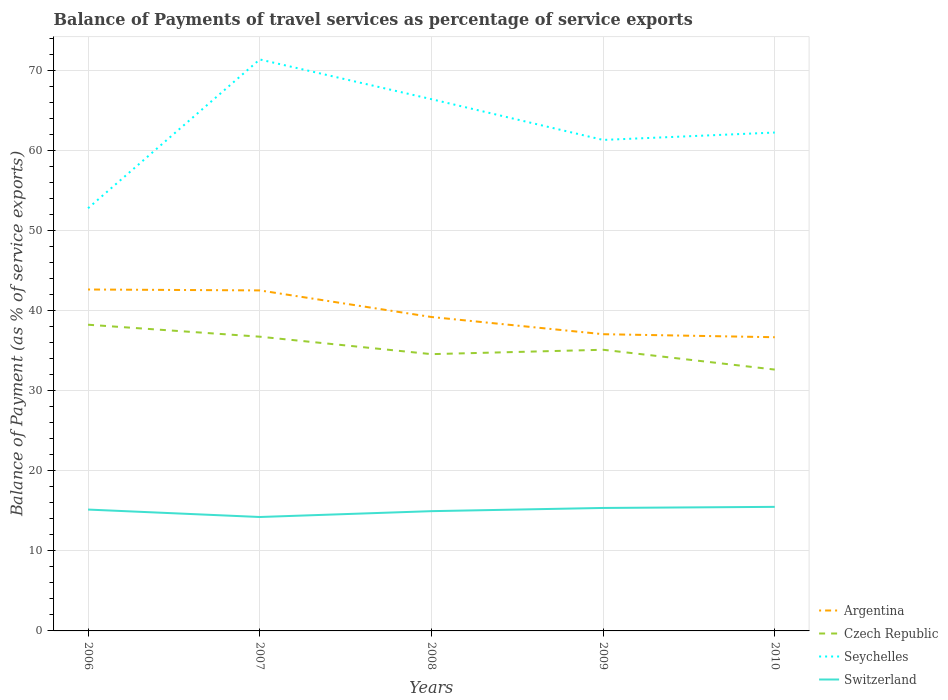Across all years, what is the maximum balance of payments of travel services in Czech Republic?
Offer a very short reply. 32.66. In which year was the balance of payments of travel services in Argentina maximum?
Provide a short and direct response. 2010. What is the total balance of payments of travel services in Czech Republic in the graph?
Your answer should be compact. 2.48. What is the difference between the highest and the second highest balance of payments of travel services in Czech Republic?
Offer a very short reply. 5.61. Is the balance of payments of travel services in Czech Republic strictly greater than the balance of payments of travel services in Seychelles over the years?
Offer a very short reply. Yes. Does the graph contain grids?
Provide a short and direct response. Yes. How many legend labels are there?
Offer a terse response. 4. How are the legend labels stacked?
Make the answer very short. Vertical. What is the title of the graph?
Your answer should be compact. Balance of Payments of travel services as percentage of service exports. Does "Arab World" appear as one of the legend labels in the graph?
Offer a terse response. No. What is the label or title of the X-axis?
Make the answer very short. Years. What is the label or title of the Y-axis?
Provide a succinct answer. Balance of Payment (as % of service exports). What is the Balance of Payment (as % of service exports) of Argentina in 2006?
Your response must be concise. 42.67. What is the Balance of Payment (as % of service exports) in Czech Republic in 2006?
Provide a short and direct response. 38.27. What is the Balance of Payment (as % of service exports) of Seychelles in 2006?
Your response must be concise. 52.83. What is the Balance of Payment (as % of service exports) of Switzerland in 2006?
Make the answer very short. 15.17. What is the Balance of Payment (as % of service exports) in Argentina in 2007?
Give a very brief answer. 42.56. What is the Balance of Payment (as % of service exports) in Czech Republic in 2007?
Your response must be concise. 36.77. What is the Balance of Payment (as % of service exports) in Seychelles in 2007?
Ensure brevity in your answer.  71.42. What is the Balance of Payment (as % of service exports) in Switzerland in 2007?
Offer a very short reply. 14.24. What is the Balance of Payment (as % of service exports) in Argentina in 2008?
Give a very brief answer. 39.23. What is the Balance of Payment (as % of service exports) of Czech Republic in 2008?
Offer a very short reply. 34.59. What is the Balance of Payment (as % of service exports) in Seychelles in 2008?
Your answer should be very brief. 66.46. What is the Balance of Payment (as % of service exports) in Switzerland in 2008?
Your answer should be compact. 14.97. What is the Balance of Payment (as % of service exports) in Argentina in 2009?
Keep it short and to the point. 37.08. What is the Balance of Payment (as % of service exports) in Czech Republic in 2009?
Your answer should be compact. 35.14. What is the Balance of Payment (as % of service exports) in Seychelles in 2009?
Offer a terse response. 61.36. What is the Balance of Payment (as % of service exports) in Switzerland in 2009?
Keep it short and to the point. 15.37. What is the Balance of Payment (as % of service exports) in Argentina in 2010?
Ensure brevity in your answer.  36.71. What is the Balance of Payment (as % of service exports) of Czech Republic in 2010?
Provide a short and direct response. 32.66. What is the Balance of Payment (as % of service exports) of Seychelles in 2010?
Your response must be concise. 62.29. What is the Balance of Payment (as % of service exports) in Switzerland in 2010?
Provide a short and direct response. 15.51. Across all years, what is the maximum Balance of Payment (as % of service exports) of Argentina?
Your response must be concise. 42.67. Across all years, what is the maximum Balance of Payment (as % of service exports) in Czech Republic?
Ensure brevity in your answer.  38.27. Across all years, what is the maximum Balance of Payment (as % of service exports) in Seychelles?
Give a very brief answer. 71.42. Across all years, what is the maximum Balance of Payment (as % of service exports) in Switzerland?
Make the answer very short. 15.51. Across all years, what is the minimum Balance of Payment (as % of service exports) of Argentina?
Provide a short and direct response. 36.71. Across all years, what is the minimum Balance of Payment (as % of service exports) of Czech Republic?
Your answer should be very brief. 32.66. Across all years, what is the minimum Balance of Payment (as % of service exports) in Seychelles?
Your answer should be compact. 52.83. Across all years, what is the minimum Balance of Payment (as % of service exports) in Switzerland?
Provide a short and direct response. 14.24. What is the total Balance of Payment (as % of service exports) in Argentina in the graph?
Provide a short and direct response. 198.25. What is the total Balance of Payment (as % of service exports) of Czech Republic in the graph?
Keep it short and to the point. 177.44. What is the total Balance of Payment (as % of service exports) in Seychelles in the graph?
Offer a very short reply. 314.36. What is the total Balance of Payment (as % of service exports) of Switzerland in the graph?
Offer a terse response. 75.25. What is the difference between the Balance of Payment (as % of service exports) in Argentina in 2006 and that in 2007?
Make the answer very short. 0.11. What is the difference between the Balance of Payment (as % of service exports) of Czech Republic in 2006 and that in 2007?
Provide a succinct answer. 1.5. What is the difference between the Balance of Payment (as % of service exports) of Seychelles in 2006 and that in 2007?
Your answer should be compact. -18.6. What is the difference between the Balance of Payment (as % of service exports) in Switzerland in 2006 and that in 2007?
Your answer should be compact. 0.93. What is the difference between the Balance of Payment (as % of service exports) in Argentina in 2006 and that in 2008?
Ensure brevity in your answer.  3.44. What is the difference between the Balance of Payment (as % of service exports) of Czech Republic in 2006 and that in 2008?
Offer a terse response. 3.68. What is the difference between the Balance of Payment (as % of service exports) of Seychelles in 2006 and that in 2008?
Offer a terse response. -13.63. What is the difference between the Balance of Payment (as % of service exports) in Switzerland in 2006 and that in 2008?
Offer a very short reply. 0.2. What is the difference between the Balance of Payment (as % of service exports) in Argentina in 2006 and that in 2009?
Ensure brevity in your answer.  5.59. What is the difference between the Balance of Payment (as % of service exports) in Czech Republic in 2006 and that in 2009?
Your answer should be compact. 3.13. What is the difference between the Balance of Payment (as % of service exports) in Seychelles in 2006 and that in 2009?
Make the answer very short. -8.54. What is the difference between the Balance of Payment (as % of service exports) of Switzerland in 2006 and that in 2009?
Offer a terse response. -0.2. What is the difference between the Balance of Payment (as % of service exports) of Argentina in 2006 and that in 2010?
Provide a short and direct response. 5.97. What is the difference between the Balance of Payment (as % of service exports) in Czech Republic in 2006 and that in 2010?
Keep it short and to the point. 5.61. What is the difference between the Balance of Payment (as % of service exports) in Seychelles in 2006 and that in 2010?
Provide a short and direct response. -9.46. What is the difference between the Balance of Payment (as % of service exports) of Switzerland in 2006 and that in 2010?
Offer a terse response. -0.34. What is the difference between the Balance of Payment (as % of service exports) of Argentina in 2007 and that in 2008?
Offer a very short reply. 3.32. What is the difference between the Balance of Payment (as % of service exports) in Czech Republic in 2007 and that in 2008?
Provide a short and direct response. 2.18. What is the difference between the Balance of Payment (as % of service exports) in Seychelles in 2007 and that in 2008?
Your response must be concise. 4.96. What is the difference between the Balance of Payment (as % of service exports) of Switzerland in 2007 and that in 2008?
Keep it short and to the point. -0.73. What is the difference between the Balance of Payment (as % of service exports) in Argentina in 2007 and that in 2009?
Offer a very short reply. 5.47. What is the difference between the Balance of Payment (as % of service exports) in Czech Republic in 2007 and that in 2009?
Your answer should be compact. 1.63. What is the difference between the Balance of Payment (as % of service exports) in Seychelles in 2007 and that in 2009?
Make the answer very short. 10.06. What is the difference between the Balance of Payment (as % of service exports) of Switzerland in 2007 and that in 2009?
Your response must be concise. -1.13. What is the difference between the Balance of Payment (as % of service exports) of Argentina in 2007 and that in 2010?
Provide a succinct answer. 5.85. What is the difference between the Balance of Payment (as % of service exports) of Czech Republic in 2007 and that in 2010?
Make the answer very short. 4.11. What is the difference between the Balance of Payment (as % of service exports) of Seychelles in 2007 and that in 2010?
Keep it short and to the point. 9.13. What is the difference between the Balance of Payment (as % of service exports) in Switzerland in 2007 and that in 2010?
Provide a succinct answer. -1.27. What is the difference between the Balance of Payment (as % of service exports) in Argentina in 2008 and that in 2009?
Make the answer very short. 2.15. What is the difference between the Balance of Payment (as % of service exports) in Czech Republic in 2008 and that in 2009?
Provide a succinct answer. -0.55. What is the difference between the Balance of Payment (as % of service exports) of Seychelles in 2008 and that in 2009?
Your answer should be very brief. 5.1. What is the difference between the Balance of Payment (as % of service exports) of Switzerland in 2008 and that in 2009?
Make the answer very short. -0.4. What is the difference between the Balance of Payment (as % of service exports) of Argentina in 2008 and that in 2010?
Keep it short and to the point. 2.53. What is the difference between the Balance of Payment (as % of service exports) in Czech Republic in 2008 and that in 2010?
Give a very brief answer. 1.93. What is the difference between the Balance of Payment (as % of service exports) in Seychelles in 2008 and that in 2010?
Provide a succinct answer. 4.17. What is the difference between the Balance of Payment (as % of service exports) of Switzerland in 2008 and that in 2010?
Your response must be concise. -0.54. What is the difference between the Balance of Payment (as % of service exports) of Argentina in 2009 and that in 2010?
Give a very brief answer. 0.38. What is the difference between the Balance of Payment (as % of service exports) in Czech Republic in 2009 and that in 2010?
Ensure brevity in your answer.  2.48. What is the difference between the Balance of Payment (as % of service exports) of Seychelles in 2009 and that in 2010?
Keep it short and to the point. -0.92. What is the difference between the Balance of Payment (as % of service exports) in Switzerland in 2009 and that in 2010?
Offer a terse response. -0.14. What is the difference between the Balance of Payment (as % of service exports) of Argentina in 2006 and the Balance of Payment (as % of service exports) of Czech Republic in 2007?
Make the answer very short. 5.9. What is the difference between the Balance of Payment (as % of service exports) in Argentina in 2006 and the Balance of Payment (as % of service exports) in Seychelles in 2007?
Ensure brevity in your answer.  -28.75. What is the difference between the Balance of Payment (as % of service exports) in Argentina in 2006 and the Balance of Payment (as % of service exports) in Switzerland in 2007?
Provide a succinct answer. 28.43. What is the difference between the Balance of Payment (as % of service exports) of Czech Republic in 2006 and the Balance of Payment (as % of service exports) of Seychelles in 2007?
Provide a short and direct response. -33.15. What is the difference between the Balance of Payment (as % of service exports) in Czech Republic in 2006 and the Balance of Payment (as % of service exports) in Switzerland in 2007?
Provide a short and direct response. 24.03. What is the difference between the Balance of Payment (as % of service exports) of Seychelles in 2006 and the Balance of Payment (as % of service exports) of Switzerland in 2007?
Ensure brevity in your answer.  38.59. What is the difference between the Balance of Payment (as % of service exports) in Argentina in 2006 and the Balance of Payment (as % of service exports) in Czech Republic in 2008?
Keep it short and to the point. 8.08. What is the difference between the Balance of Payment (as % of service exports) in Argentina in 2006 and the Balance of Payment (as % of service exports) in Seychelles in 2008?
Provide a succinct answer. -23.79. What is the difference between the Balance of Payment (as % of service exports) of Argentina in 2006 and the Balance of Payment (as % of service exports) of Switzerland in 2008?
Give a very brief answer. 27.7. What is the difference between the Balance of Payment (as % of service exports) of Czech Republic in 2006 and the Balance of Payment (as % of service exports) of Seychelles in 2008?
Make the answer very short. -28.19. What is the difference between the Balance of Payment (as % of service exports) of Czech Republic in 2006 and the Balance of Payment (as % of service exports) of Switzerland in 2008?
Provide a succinct answer. 23.3. What is the difference between the Balance of Payment (as % of service exports) in Seychelles in 2006 and the Balance of Payment (as % of service exports) in Switzerland in 2008?
Your answer should be compact. 37.86. What is the difference between the Balance of Payment (as % of service exports) of Argentina in 2006 and the Balance of Payment (as % of service exports) of Czech Republic in 2009?
Make the answer very short. 7.53. What is the difference between the Balance of Payment (as % of service exports) of Argentina in 2006 and the Balance of Payment (as % of service exports) of Seychelles in 2009?
Make the answer very short. -18.69. What is the difference between the Balance of Payment (as % of service exports) in Argentina in 2006 and the Balance of Payment (as % of service exports) in Switzerland in 2009?
Offer a very short reply. 27.3. What is the difference between the Balance of Payment (as % of service exports) in Czech Republic in 2006 and the Balance of Payment (as % of service exports) in Seychelles in 2009?
Offer a terse response. -23.09. What is the difference between the Balance of Payment (as % of service exports) in Czech Republic in 2006 and the Balance of Payment (as % of service exports) in Switzerland in 2009?
Ensure brevity in your answer.  22.9. What is the difference between the Balance of Payment (as % of service exports) in Seychelles in 2006 and the Balance of Payment (as % of service exports) in Switzerland in 2009?
Ensure brevity in your answer.  37.46. What is the difference between the Balance of Payment (as % of service exports) in Argentina in 2006 and the Balance of Payment (as % of service exports) in Czech Republic in 2010?
Provide a short and direct response. 10.01. What is the difference between the Balance of Payment (as % of service exports) in Argentina in 2006 and the Balance of Payment (as % of service exports) in Seychelles in 2010?
Your answer should be compact. -19.62. What is the difference between the Balance of Payment (as % of service exports) in Argentina in 2006 and the Balance of Payment (as % of service exports) in Switzerland in 2010?
Make the answer very short. 27.17. What is the difference between the Balance of Payment (as % of service exports) in Czech Republic in 2006 and the Balance of Payment (as % of service exports) in Seychelles in 2010?
Your answer should be very brief. -24.02. What is the difference between the Balance of Payment (as % of service exports) in Czech Republic in 2006 and the Balance of Payment (as % of service exports) in Switzerland in 2010?
Keep it short and to the point. 22.76. What is the difference between the Balance of Payment (as % of service exports) of Seychelles in 2006 and the Balance of Payment (as % of service exports) of Switzerland in 2010?
Offer a very short reply. 37.32. What is the difference between the Balance of Payment (as % of service exports) of Argentina in 2007 and the Balance of Payment (as % of service exports) of Czech Republic in 2008?
Provide a short and direct response. 7.97. What is the difference between the Balance of Payment (as % of service exports) of Argentina in 2007 and the Balance of Payment (as % of service exports) of Seychelles in 2008?
Keep it short and to the point. -23.9. What is the difference between the Balance of Payment (as % of service exports) in Argentina in 2007 and the Balance of Payment (as % of service exports) in Switzerland in 2008?
Provide a succinct answer. 27.59. What is the difference between the Balance of Payment (as % of service exports) of Czech Republic in 2007 and the Balance of Payment (as % of service exports) of Seychelles in 2008?
Provide a short and direct response. -29.69. What is the difference between the Balance of Payment (as % of service exports) in Czech Republic in 2007 and the Balance of Payment (as % of service exports) in Switzerland in 2008?
Provide a short and direct response. 21.81. What is the difference between the Balance of Payment (as % of service exports) in Seychelles in 2007 and the Balance of Payment (as % of service exports) in Switzerland in 2008?
Make the answer very short. 56.46. What is the difference between the Balance of Payment (as % of service exports) in Argentina in 2007 and the Balance of Payment (as % of service exports) in Czech Republic in 2009?
Provide a succinct answer. 7.42. What is the difference between the Balance of Payment (as % of service exports) in Argentina in 2007 and the Balance of Payment (as % of service exports) in Seychelles in 2009?
Your answer should be compact. -18.81. What is the difference between the Balance of Payment (as % of service exports) in Argentina in 2007 and the Balance of Payment (as % of service exports) in Switzerland in 2009?
Keep it short and to the point. 27.19. What is the difference between the Balance of Payment (as % of service exports) of Czech Republic in 2007 and the Balance of Payment (as % of service exports) of Seychelles in 2009?
Provide a succinct answer. -24.59. What is the difference between the Balance of Payment (as % of service exports) in Czech Republic in 2007 and the Balance of Payment (as % of service exports) in Switzerland in 2009?
Offer a very short reply. 21.41. What is the difference between the Balance of Payment (as % of service exports) in Seychelles in 2007 and the Balance of Payment (as % of service exports) in Switzerland in 2009?
Your answer should be compact. 56.05. What is the difference between the Balance of Payment (as % of service exports) of Argentina in 2007 and the Balance of Payment (as % of service exports) of Czech Republic in 2010?
Make the answer very short. 9.9. What is the difference between the Balance of Payment (as % of service exports) of Argentina in 2007 and the Balance of Payment (as % of service exports) of Seychelles in 2010?
Your answer should be compact. -19.73. What is the difference between the Balance of Payment (as % of service exports) of Argentina in 2007 and the Balance of Payment (as % of service exports) of Switzerland in 2010?
Provide a short and direct response. 27.05. What is the difference between the Balance of Payment (as % of service exports) of Czech Republic in 2007 and the Balance of Payment (as % of service exports) of Seychelles in 2010?
Give a very brief answer. -25.51. What is the difference between the Balance of Payment (as % of service exports) in Czech Republic in 2007 and the Balance of Payment (as % of service exports) in Switzerland in 2010?
Your answer should be compact. 21.27. What is the difference between the Balance of Payment (as % of service exports) of Seychelles in 2007 and the Balance of Payment (as % of service exports) of Switzerland in 2010?
Your answer should be very brief. 55.92. What is the difference between the Balance of Payment (as % of service exports) of Argentina in 2008 and the Balance of Payment (as % of service exports) of Czech Republic in 2009?
Ensure brevity in your answer.  4.09. What is the difference between the Balance of Payment (as % of service exports) of Argentina in 2008 and the Balance of Payment (as % of service exports) of Seychelles in 2009?
Provide a succinct answer. -22.13. What is the difference between the Balance of Payment (as % of service exports) of Argentina in 2008 and the Balance of Payment (as % of service exports) of Switzerland in 2009?
Ensure brevity in your answer.  23.87. What is the difference between the Balance of Payment (as % of service exports) in Czech Republic in 2008 and the Balance of Payment (as % of service exports) in Seychelles in 2009?
Provide a short and direct response. -26.77. What is the difference between the Balance of Payment (as % of service exports) of Czech Republic in 2008 and the Balance of Payment (as % of service exports) of Switzerland in 2009?
Offer a very short reply. 19.22. What is the difference between the Balance of Payment (as % of service exports) in Seychelles in 2008 and the Balance of Payment (as % of service exports) in Switzerland in 2009?
Keep it short and to the point. 51.09. What is the difference between the Balance of Payment (as % of service exports) of Argentina in 2008 and the Balance of Payment (as % of service exports) of Czech Republic in 2010?
Provide a short and direct response. 6.57. What is the difference between the Balance of Payment (as % of service exports) of Argentina in 2008 and the Balance of Payment (as % of service exports) of Seychelles in 2010?
Your answer should be compact. -23.05. What is the difference between the Balance of Payment (as % of service exports) of Argentina in 2008 and the Balance of Payment (as % of service exports) of Switzerland in 2010?
Your answer should be compact. 23.73. What is the difference between the Balance of Payment (as % of service exports) of Czech Republic in 2008 and the Balance of Payment (as % of service exports) of Seychelles in 2010?
Your answer should be very brief. -27.7. What is the difference between the Balance of Payment (as % of service exports) in Czech Republic in 2008 and the Balance of Payment (as % of service exports) in Switzerland in 2010?
Give a very brief answer. 19.09. What is the difference between the Balance of Payment (as % of service exports) in Seychelles in 2008 and the Balance of Payment (as % of service exports) in Switzerland in 2010?
Provide a succinct answer. 50.95. What is the difference between the Balance of Payment (as % of service exports) in Argentina in 2009 and the Balance of Payment (as % of service exports) in Czech Republic in 2010?
Give a very brief answer. 4.42. What is the difference between the Balance of Payment (as % of service exports) of Argentina in 2009 and the Balance of Payment (as % of service exports) of Seychelles in 2010?
Offer a very short reply. -25.2. What is the difference between the Balance of Payment (as % of service exports) in Argentina in 2009 and the Balance of Payment (as % of service exports) in Switzerland in 2010?
Your answer should be compact. 21.58. What is the difference between the Balance of Payment (as % of service exports) in Czech Republic in 2009 and the Balance of Payment (as % of service exports) in Seychelles in 2010?
Provide a short and direct response. -27.15. What is the difference between the Balance of Payment (as % of service exports) of Czech Republic in 2009 and the Balance of Payment (as % of service exports) of Switzerland in 2010?
Offer a very short reply. 19.64. What is the difference between the Balance of Payment (as % of service exports) in Seychelles in 2009 and the Balance of Payment (as % of service exports) in Switzerland in 2010?
Your answer should be compact. 45.86. What is the average Balance of Payment (as % of service exports) of Argentina per year?
Give a very brief answer. 39.65. What is the average Balance of Payment (as % of service exports) in Czech Republic per year?
Your answer should be very brief. 35.49. What is the average Balance of Payment (as % of service exports) of Seychelles per year?
Ensure brevity in your answer.  62.87. What is the average Balance of Payment (as % of service exports) in Switzerland per year?
Your answer should be compact. 15.05. In the year 2006, what is the difference between the Balance of Payment (as % of service exports) of Argentina and Balance of Payment (as % of service exports) of Czech Republic?
Make the answer very short. 4.4. In the year 2006, what is the difference between the Balance of Payment (as % of service exports) in Argentina and Balance of Payment (as % of service exports) in Seychelles?
Your answer should be compact. -10.15. In the year 2006, what is the difference between the Balance of Payment (as % of service exports) in Argentina and Balance of Payment (as % of service exports) in Switzerland?
Keep it short and to the point. 27.5. In the year 2006, what is the difference between the Balance of Payment (as % of service exports) in Czech Republic and Balance of Payment (as % of service exports) in Seychelles?
Give a very brief answer. -14.56. In the year 2006, what is the difference between the Balance of Payment (as % of service exports) in Czech Republic and Balance of Payment (as % of service exports) in Switzerland?
Offer a very short reply. 23.1. In the year 2006, what is the difference between the Balance of Payment (as % of service exports) in Seychelles and Balance of Payment (as % of service exports) in Switzerland?
Offer a very short reply. 37.66. In the year 2007, what is the difference between the Balance of Payment (as % of service exports) of Argentina and Balance of Payment (as % of service exports) of Czech Republic?
Provide a succinct answer. 5.78. In the year 2007, what is the difference between the Balance of Payment (as % of service exports) in Argentina and Balance of Payment (as % of service exports) in Seychelles?
Give a very brief answer. -28.86. In the year 2007, what is the difference between the Balance of Payment (as % of service exports) of Argentina and Balance of Payment (as % of service exports) of Switzerland?
Make the answer very short. 28.32. In the year 2007, what is the difference between the Balance of Payment (as % of service exports) in Czech Republic and Balance of Payment (as % of service exports) in Seychelles?
Your response must be concise. -34.65. In the year 2007, what is the difference between the Balance of Payment (as % of service exports) in Czech Republic and Balance of Payment (as % of service exports) in Switzerland?
Offer a terse response. 22.54. In the year 2007, what is the difference between the Balance of Payment (as % of service exports) of Seychelles and Balance of Payment (as % of service exports) of Switzerland?
Your answer should be compact. 57.19. In the year 2008, what is the difference between the Balance of Payment (as % of service exports) of Argentina and Balance of Payment (as % of service exports) of Czech Republic?
Make the answer very short. 4.64. In the year 2008, what is the difference between the Balance of Payment (as % of service exports) of Argentina and Balance of Payment (as % of service exports) of Seychelles?
Your answer should be very brief. -27.23. In the year 2008, what is the difference between the Balance of Payment (as % of service exports) in Argentina and Balance of Payment (as % of service exports) in Switzerland?
Provide a succinct answer. 24.27. In the year 2008, what is the difference between the Balance of Payment (as % of service exports) of Czech Republic and Balance of Payment (as % of service exports) of Seychelles?
Your answer should be very brief. -31.87. In the year 2008, what is the difference between the Balance of Payment (as % of service exports) of Czech Republic and Balance of Payment (as % of service exports) of Switzerland?
Offer a terse response. 19.62. In the year 2008, what is the difference between the Balance of Payment (as % of service exports) of Seychelles and Balance of Payment (as % of service exports) of Switzerland?
Your response must be concise. 51.49. In the year 2009, what is the difference between the Balance of Payment (as % of service exports) in Argentina and Balance of Payment (as % of service exports) in Czech Republic?
Your answer should be very brief. 1.94. In the year 2009, what is the difference between the Balance of Payment (as % of service exports) of Argentina and Balance of Payment (as % of service exports) of Seychelles?
Offer a very short reply. -24.28. In the year 2009, what is the difference between the Balance of Payment (as % of service exports) in Argentina and Balance of Payment (as % of service exports) in Switzerland?
Give a very brief answer. 21.72. In the year 2009, what is the difference between the Balance of Payment (as % of service exports) in Czech Republic and Balance of Payment (as % of service exports) in Seychelles?
Your answer should be compact. -26.22. In the year 2009, what is the difference between the Balance of Payment (as % of service exports) in Czech Republic and Balance of Payment (as % of service exports) in Switzerland?
Provide a short and direct response. 19.77. In the year 2009, what is the difference between the Balance of Payment (as % of service exports) of Seychelles and Balance of Payment (as % of service exports) of Switzerland?
Provide a short and direct response. 46. In the year 2010, what is the difference between the Balance of Payment (as % of service exports) in Argentina and Balance of Payment (as % of service exports) in Czech Republic?
Provide a succinct answer. 4.04. In the year 2010, what is the difference between the Balance of Payment (as % of service exports) of Argentina and Balance of Payment (as % of service exports) of Seychelles?
Provide a succinct answer. -25.58. In the year 2010, what is the difference between the Balance of Payment (as % of service exports) in Argentina and Balance of Payment (as % of service exports) in Switzerland?
Your answer should be compact. 21.2. In the year 2010, what is the difference between the Balance of Payment (as % of service exports) in Czech Republic and Balance of Payment (as % of service exports) in Seychelles?
Your answer should be very brief. -29.63. In the year 2010, what is the difference between the Balance of Payment (as % of service exports) in Czech Republic and Balance of Payment (as % of service exports) in Switzerland?
Make the answer very short. 17.16. In the year 2010, what is the difference between the Balance of Payment (as % of service exports) of Seychelles and Balance of Payment (as % of service exports) of Switzerland?
Give a very brief answer. 46.78. What is the ratio of the Balance of Payment (as % of service exports) of Argentina in 2006 to that in 2007?
Offer a very short reply. 1. What is the ratio of the Balance of Payment (as % of service exports) in Czech Republic in 2006 to that in 2007?
Offer a very short reply. 1.04. What is the ratio of the Balance of Payment (as % of service exports) in Seychelles in 2006 to that in 2007?
Offer a very short reply. 0.74. What is the ratio of the Balance of Payment (as % of service exports) of Switzerland in 2006 to that in 2007?
Give a very brief answer. 1.07. What is the ratio of the Balance of Payment (as % of service exports) in Argentina in 2006 to that in 2008?
Give a very brief answer. 1.09. What is the ratio of the Balance of Payment (as % of service exports) in Czech Republic in 2006 to that in 2008?
Offer a very short reply. 1.11. What is the ratio of the Balance of Payment (as % of service exports) in Seychelles in 2006 to that in 2008?
Ensure brevity in your answer.  0.79. What is the ratio of the Balance of Payment (as % of service exports) in Switzerland in 2006 to that in 2008?
Your response must be concise. 1.01. What is the ratio of the Balance of Payment (as % of service exports) in Argentina in 2006 to that in 2009?
Provide a succinct answer. 1.15. What is the ratio of the Balance of Payment (as % of service exports) of Czech Republic in 2006 to that in 2009?
Provide a succinct answer. 1.09. What is the ratio of the Balance of Payment (as % of service exports) of Seychelles in 2006 to that in 2009?
Provide a short and direct response. 0.86. What is the ratio of the Balance of Payment (as % of service exports) of Switzerland in 2006 to that in 2009?
Make the answer very short. 0.99. What is the ratio of the Balance of Payment (as % of service exports) of Argentina in 2006 to that in 2010?
Offer a very short reply. 1.16. What is the ratio of the Balance of Payment (as % of service exports) of Czech Republic in 2006 to that in 2010?
Your answer should be compact. 1.17. What is the ratio of the Balance of Payment (as % of service exports) in Seychelles in 2006 to that in 2010?
Your answer should be compact. 0.85. What is the ratio of the Balance of Payment (as % of service exports) in Switzerland in 2006 to that in 2010?
Keep it short and to the point. 0.98. What is the ratio of the Balance of Payment (as % of service exports) in Argentina in 2007 to that in 2008?
Provide a short and direct response. 1.08. What is the ratio of the Balance of Payment (as % of service exports) in Czech Republic in 2007 to that in 2008?
Your answer should be very brief. 1.06. What is the ratio of the Balance of Payment (as % of service exports) in Seychelles in 2007 to that in 2008?
Offer a terse response. 1.07. What is the ratio of the Balance of Payment (as % of service exports) of Switzerland in 2007 to that in 2008?
Provide a short and direct response. 0.95. What is the ratio of the Balance of Payment (as % of service exports) of Argentina in 2007 to that in 2009?
Provide a succinct answer. 1.15. What is the ratio of the Balance of Payment (as % of service exports) in Czech Republic in 2007 to that in 2009?
Ensure brevity in your answer.  1.05. What is the ratio of the Balance of Payment (as % of service exports) in Seychelles in 2007 to that in 2009?
Offer a very short reply. 1.16. What is the ratio of the Balance of Payment (as % of service exports) in Switzerland in 2007 to that in 2009?
Make the answer very short. 0.93. What is the ratio of the Balance of Payment (as % of service exports) of Argentina in 2007 to that in 2010?
Your response must be concise. 1.16. What is the ratio of the Balance of Payment (as % of service exports) of Czech Republic in 2007 to that in 2010?
Keep it short and to the point. 1.13. What is the ratio of the Balance of Payment (as % of service exports) of Seychelles in 2007 to that in 2010?
Your response must be concise. 1.15. What is the ratio of the Balance of Payment (as % of service exports) of Switzerland in 2007 to that in 2010?
Provide a short and direct response. 0.92. What is the ratio of the Balance of Payment (as % of service exports) in Argentina in 2008 to that in 2009?
Provide a succinct answer. 1.06. What is the ratio of the Balance of Payment (as % of service exports) of Czech Republic in 2008 to that in 2009?
Give a very brief answer. 0.98. What is the ratio of the Balance of Payment (as % of service exports) in Seychelles in 2008 to that in 2009?
Your answer should be compact. 1.08. What is the ratio of the Balance of Payment (as % of service exports) in Switzerland in 2008 to that in 2009?
Provide a short and direct response. 0.97. What is the ratio of the Balance of Payment (as % of service exports) of Argentina in 2008 to that in 2010?
Your answer should be very brief. 1.07. What is the ratio of the Balance of Payment (as % of service exports) in Czech Republic in 2008 to that in 2010?
Provide a succinct answer. 1.06. What is the ratio of the Balance of Payment (as % of service exports) of Seychelles in 2008 to that in 2010?
Keep it short and to the point. 1.07. What is the ratio of the Balance of Payment (as % of service exports) of Switzerland in 2008 to that in 2010?
Keep it short and to the point. 0.97. What is the ratio of the Balance of Payment (as % of service exports) in Argentina in 2009 to that in 2010?
Make the answer very short. 1.01. What is the ratio of the Balance of Payment (as % of service exports) in Czech Republic in 2009 to that in 2010?
Your response must be concise. 1.08. What is the ratio of the Balance of Payment (as % of service exports) in Seychelles in 2009 to that in 2010?
Ensure brevity in your answer.  0.99. What is the ratio of the Balance of Payment (as % of service exports) of Switzerland in 2009 to that in 2010?
Provide a short and direct response. 0.99. What is the difference between the highest and the second highest Balance of Payment (as % of service exports) in Argentina?
Provide a short and direct response. 0.11. What is the difference between the highest and the second highest Balance of Payment (as % of service exports) of Czech Republic?
Your response must be concise. 1.5. What is the difference between the highest and the second highest Balance of Payment (as % of service exports) of Seychelles?
Ensure brevity in your answer.  4.96. What is the difference between the highest and the second highest Balance of Payment (as % of service exports) of Switzerland?
Offer a terse response. 0.14. What is the difference between the highest and the lowest Balance of Payment (as % of service exports) in Argentina?
Make the answer very short. 5.97. What is the difference between the highest and the lowest Balance of Payment (as % of service exports) in Czech Republic?
Ensure brevity in your answer.  5.61. What is the difference between the highest and the lowest Balance of Payment (as % of service exports) of Seychelles?
Provide a succinct answer. 18.6. What is the difference between the highest and the lowest Balance of Payment (as % of service exports) of Switzerland?
Provide a succinct answer. 1.27. 